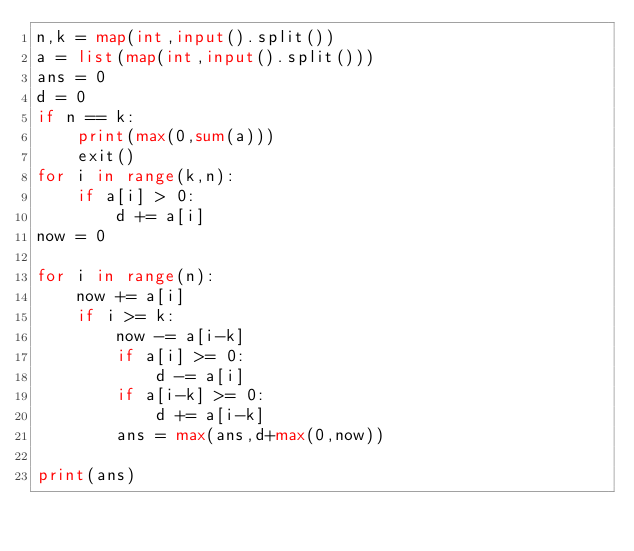Convert code to text. <code><loc_0><loc_0><loc_500><loc_500><_Python_>n,k = map(int,input().split())
a = list(map(int,input().split()))
ans = 0
d = 0
if n == k:
    print(max(0,sum(a)))
    exit()
for i in range(k,n):
    if a[i] > 0:
        d += a[i]
now = 0

for i in range(n):
    now += a[i]
    if i >= k:
        now -= a[i-k]
        if a[i] >= 0:
            d -= a[i]
        if a[i-k] >= 0:
            d += a[i-k]
        ans = max(ans,d+max(0,now))
    
print(ans)</code> 